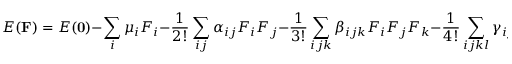Convert formula to latex. <formula><loc_0><loc_0><loc_500><loc_500>E ( { F } ) = E ( { 0 } ) - \sum _ { i } \mu _ { i } F _ { i } - \frac { 1 } { 2 ! } \sum _ { i j } \alpha _ { i j } F _ { i } F _ { j } - \frac { 1 } { 3 ! } \sum _ { i j k } \beta _ { i j k } F _ { i } F _ { j } F _ { k } - \frac { 1 } { 4 ! } \sum _ { i j k l } \gamma _ { i j k l } F _ { i } F _ { j } F _ { k } F _ { l } + \dots</formula> 